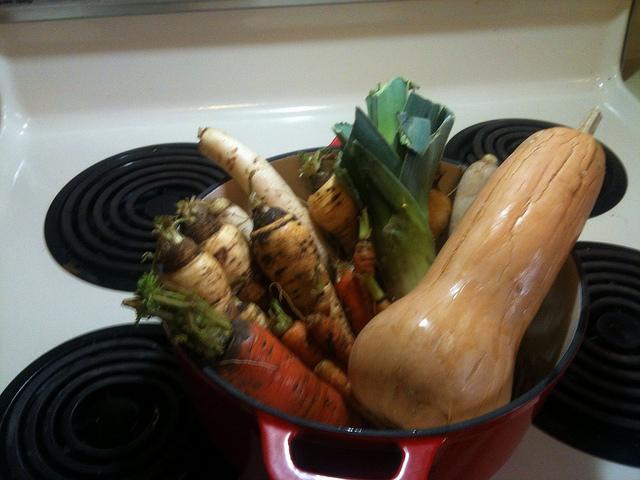How many different types of veggie are in this image?
Give a very brief answer. 4. How many burners are on the stove?
Give a very brief answer. 4. How many carrots are in the photo?
Give a very brief answer. 3. How many sandwiches with orange paste are in the picture?
Give a very brief answer. 0. 